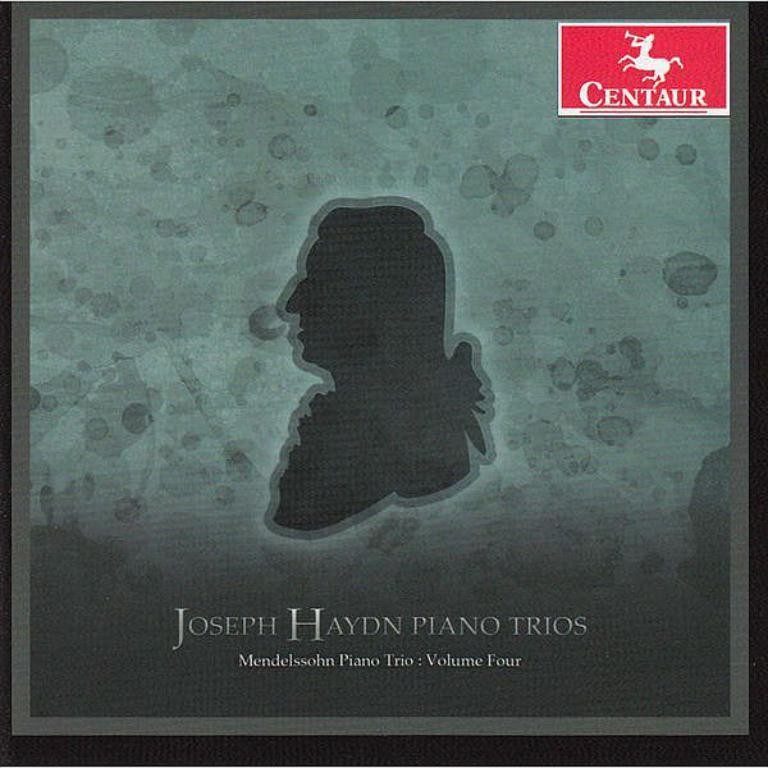<image>
Summarize the visual content of the image. a photo of Joseph Haydn piano trios and a centaur logo 